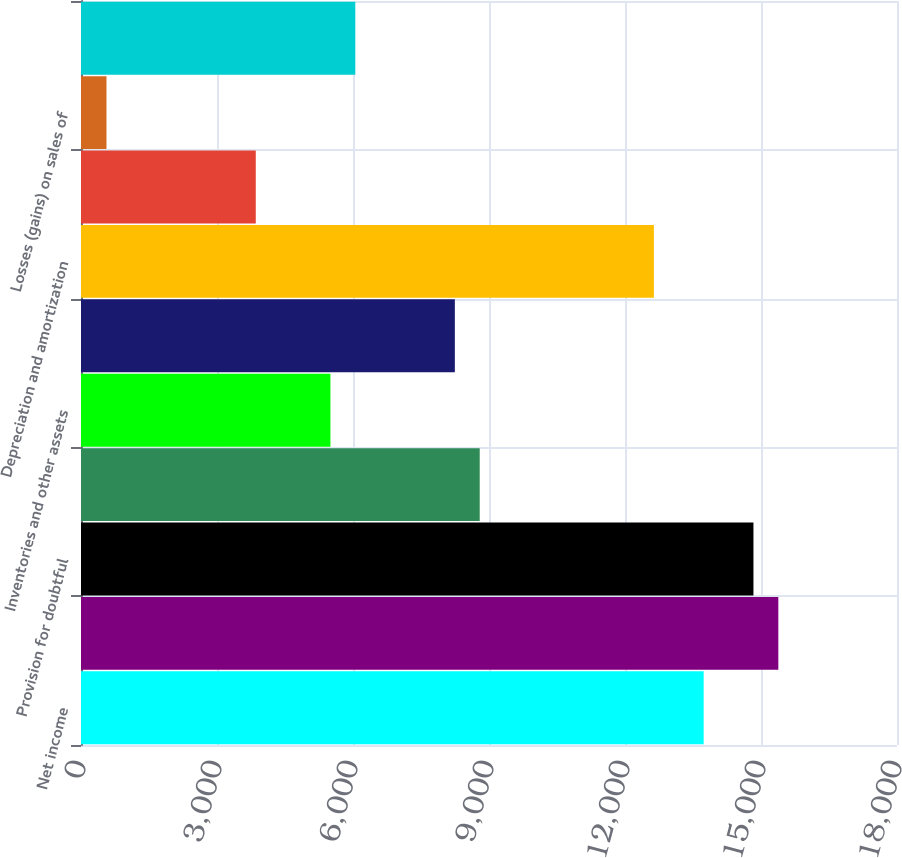<chart> <loc_0><loc_0><loc_500><loc_500><bar_chart><fcel>Net income<fcel>Accounts receivable<fcel>Provision for doubtful<fcel>Accounts receivable net<fcel>Inventories and other assets<fcel>Accounts payable and accrued<fcel>Depreciation and amortization<fcel>Income taxes<fcel>Losses (gains) on sales of<fcel>Losses on retirement of debt<nl><fcel>13735.5<fcel>15382.2<fcel>14833.3<fcel>8795.4<fcel>5502<fcel>8246.5<fcel>12637.7<fcel>3855.3<fcel>561.9<fcel>6050.9<nl></chart> 